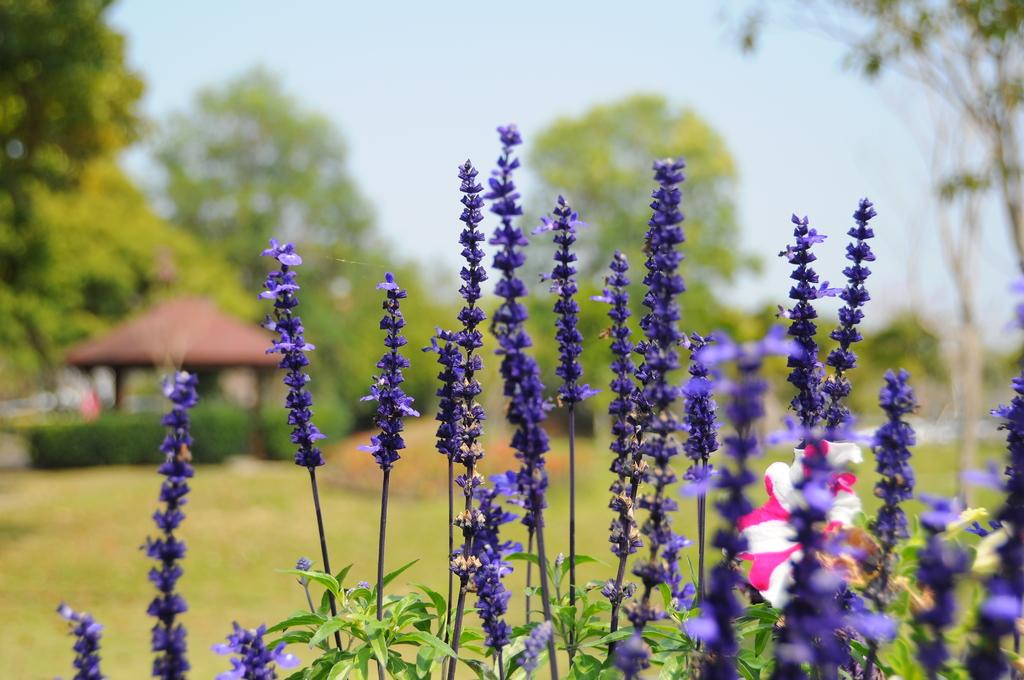What color are the flowers in the image? There are purple colored flowers and a pink and white colored flower in the image. Can you describe the appearance of the flowers in more detail? The background of the plant is blurred. What type of milk can be seen being poured on the flowers in the image? There is no milk present in the image; it features flowers with a blurred background. 